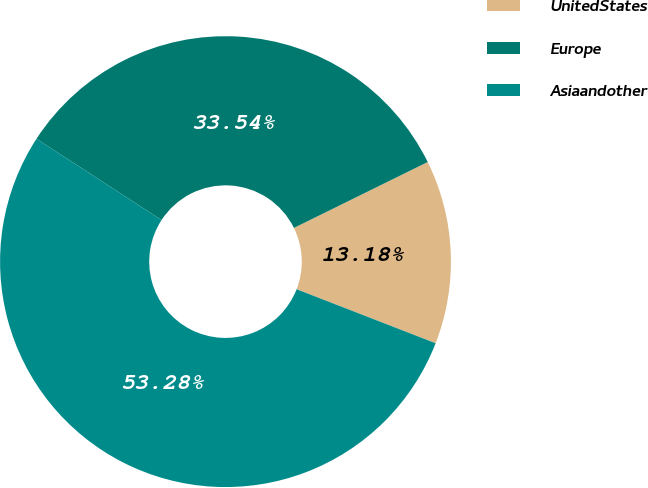Convert chart to OTSL. <chart><loc_0><loc_0><loc_500><loc_500><pie_chart><fcel>UnitedStates<fcel>Europe<fcel>Asiaandother<nl><fcel>13.18%<fcel>33.54%<fcel>53.27%<nl></chart> 